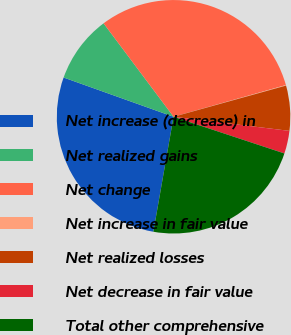Convert chart. <chart><loc_0><loc_0><loc_500><loc_500><pie_chart><fcel>Net increase (decrease) in<fcel>Net realized gains<fcel>Net change<fcel>Net increase in fair value<fcel>Net realized losses<fcel>Net decrease in fair value<fcel>Total other comprehensive<nl><fcel>27.69%<fcel>9.31%<fcel>30.85%<fcel>0.08%<fcel>6.23%<fcel>3.16%<fcel>22.68%<nl></chart> 